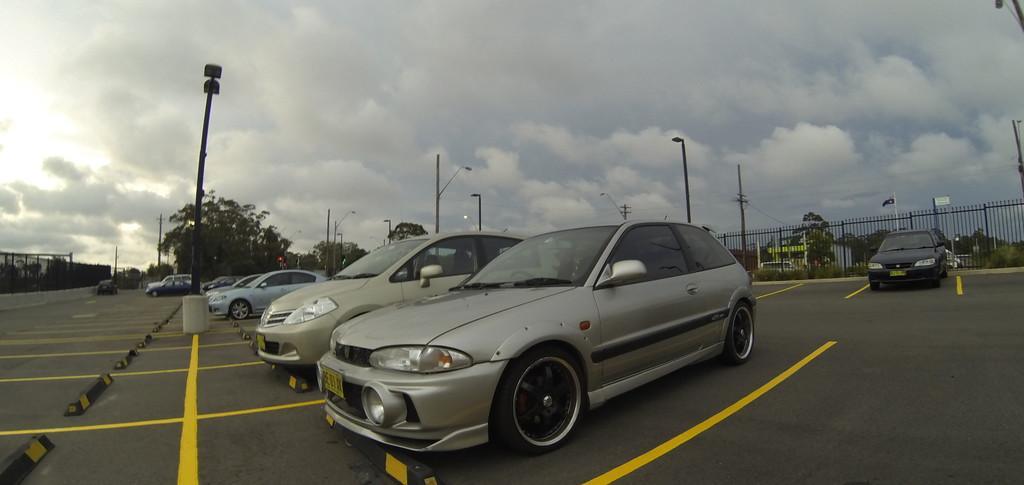How would you summarize this image in a sentence or two? In this picture we can see cars on the road, poles, fences, trees and some objects and in the background we can see the sky with clouds. 